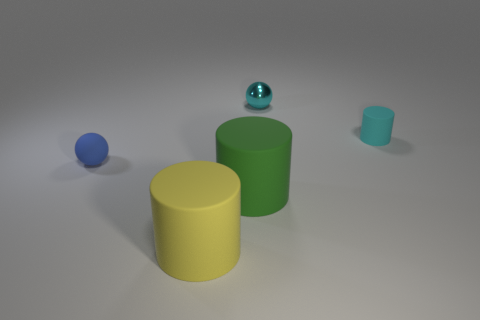Add 2 cyan blocks. How many objects exist? 7 Subtract all cylinders. How many objects are left? 2 Add 1 yellow objects. How many yellow objects are left? 2 Add 5 tiny matte cylinders. How many tiny matte cylinders exist? 6 Subtract 0 green cubes. How many objects are left? 5 Subtract all cyan rubber objects. Subtract all tiny cyan matte objects. How many objects are left? 3 